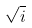<formula> <loc_0><loc_0><loc_500><loc_500>\sqrt { i }</formula> 